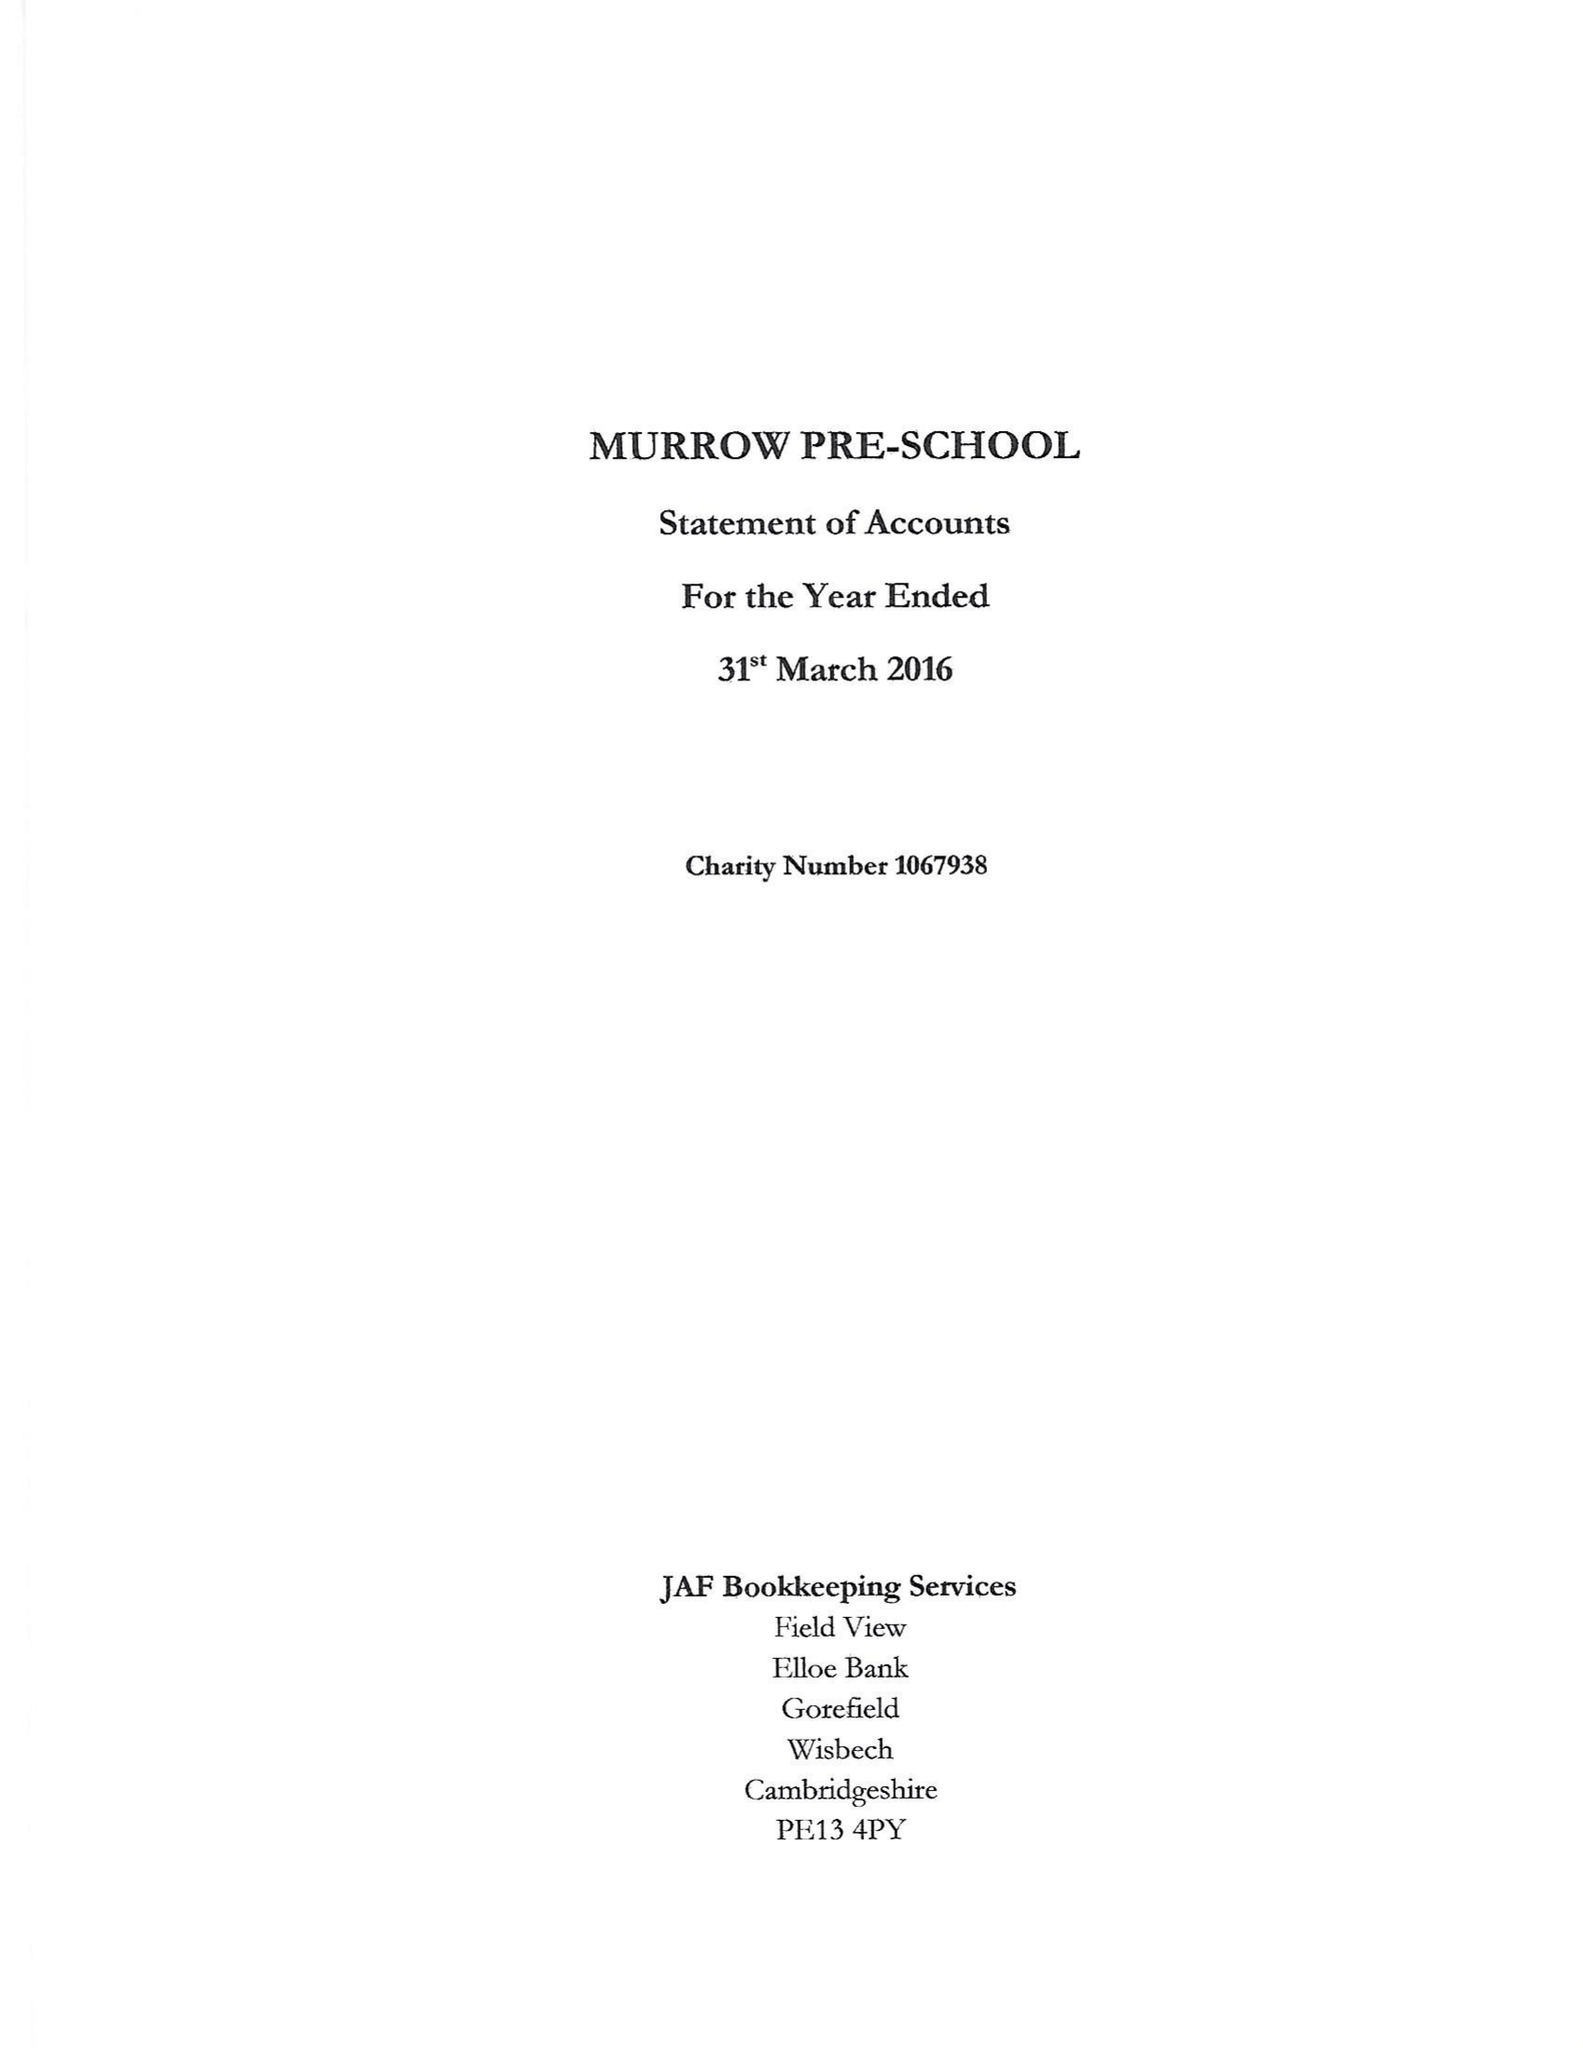What is the value for the spending_annually_in_british_pounds?
Answer the question using a single word or phrase. 77721.00 